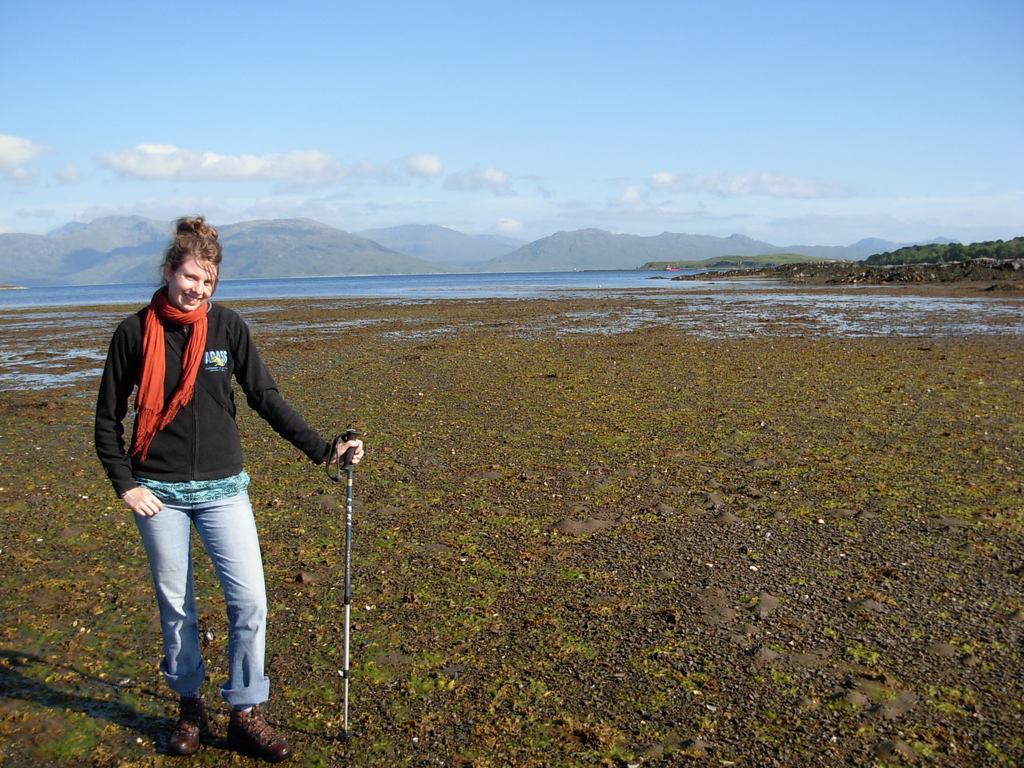Could you give a brief overview of what you see in this image? In the picture I can see a woman on the left side and there is a smile on her face. She is wearing a black color jacket and she is holding a golf handle in her left hand. In the background, I can see the ocean and mountains. There are clouds in the sky. 